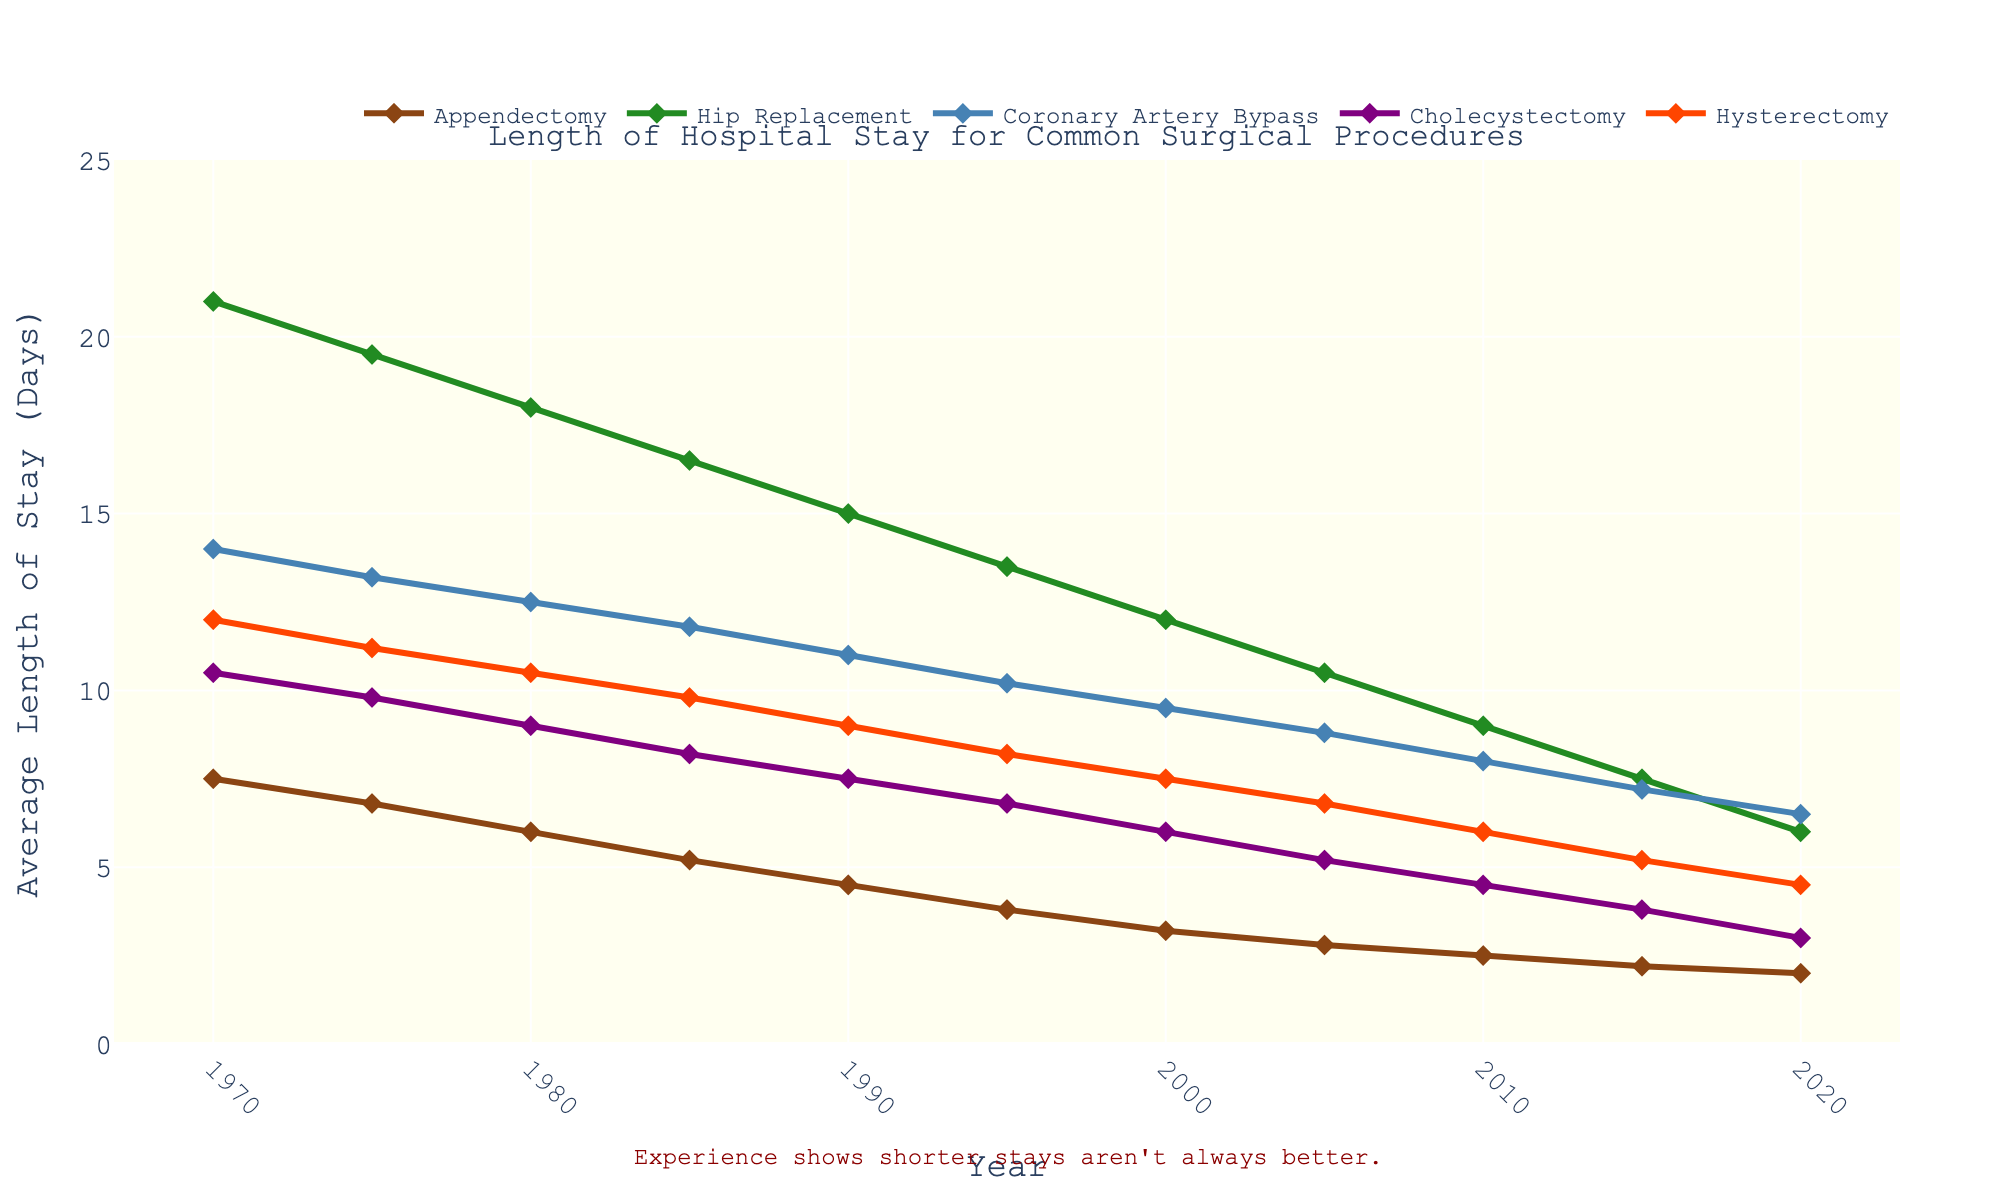Which procedure had the shortest average hospital stay in 2020? Look at the year 2020 on the x-axis, find the lowest y-value among all the procedures. The Cholecystectomy had an average hospital stay of 3.0 days, the shortest among all procedures in 2020.
Answer: Cholecystectomy Which surgery shows the greatest decrease in average length of hospital stay from 1970 to 2020? Subtract the 2020 value from the 1970 value for each procedure. The greatest decrease in length of stay is for Hip Replacement, which fell from 21.0 to 6.0 days, a decrease of 15.0 days.
Answer: Hip Replacement Which surgical procedure had the smallest change in the average length of stay over the period shown? Compute the difference in hospital stay from 1970 to 2020 for all procedures. Appendectomy decreased from 7.5 days in 1970 to 2.0 days in 2020, a change of 5.5 days, which is the smallest change among all procedures.
Answer: Appendectomy Was hysterotomy's average length of hospital stay consistently decreasing from 1970 to 2020? Check the y-values for Hysterectomy from left to right from 1970 to 2020. The values show a consistent decrease from 12.0 (1970) to 4.5 (2020), indicating a steady downward trend.
Answer: Yes In which year did the average hospital stay for Cholecystectomy first drop below 5 days? Review the y-values of Cholecystectomy across the years. In 2005, the value dropped to 5.2, then in 2010, it went to 4.5, which is the first year it fell below 5.
Answer: 2010 Compare the lengths of hospital stay for Appendectomy and Hip Replacement in 1980. Which one was shorter, and by how many days? Look at the y-values for both procedures in 1980. Appendectomy had 6.0 days, and Hip Replacement had 18.0 days. Hence, Appendectomy was shorter by 18.0 - 6.0 = 12 days.
Answer: Appendectomy, by 12 days What was the average length of stay across all procedures in 1995? Add the lengths of stay in 1995 for all procedures and divide by the number of procedures. (3.8 + 13.5 + 10.2 + 6.8 + 8.2) / 5 = 8.5 days.
Answer: 8.5 days How many years did it take for the average hospital stay for Hip Replacement to drop from 21.0 days to below 10 days? Identify when Hip Replacement stays were below 10 days and subtract the initial year. The average dropped below 10 days in 2005, starting from 1970, which is 35 years.
Answer: 35 years 